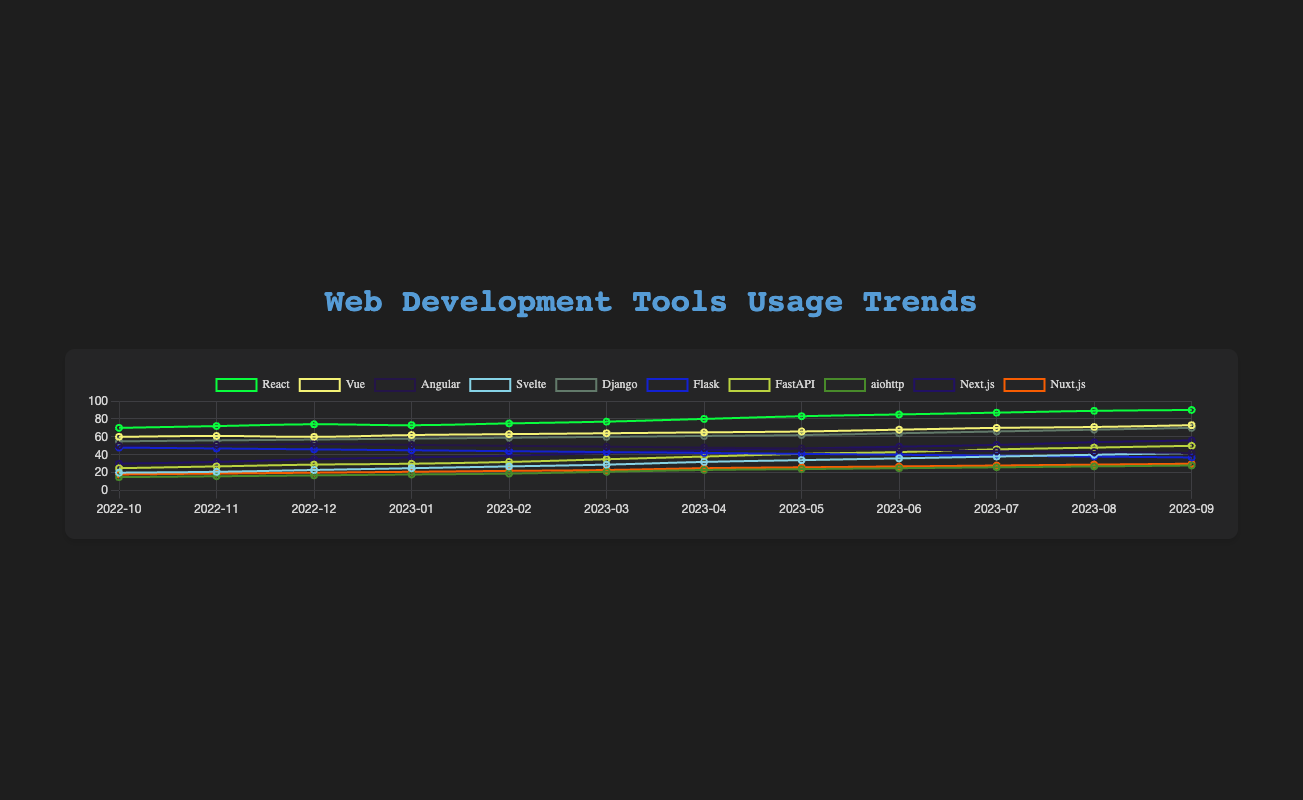What's the trend for React from October 2022 to September 2023? React's usage starts at 70% in October 2022 and shows a general upward trend, ending at 90% in September 2023, indicating increasing popularity.
Answer: Increasing Which tool has shown the most consistent increase in usage? By examining the slopes of the lines, we see that Django has a steady increase from 55% to 70%, and Next.js from 30% to 56% over the year. Both show consistent increases, but Next.js has a steeper slope, indicating a faster growth rate.
Answer: Next.js Between FastAPI and aiohttp, which had a higher usage in May 2023? FastAPI shows a usage of 41% while aiohttp shows 24% in May 2023.
Answer: FastAPI Compare the usage of Vue and Angular in March 2023. Which one was more popular? In March 2023, Vue has a usage of 64% and Angular has 49%, indicating Vue is more popular at that time.
Answer: Vue Which tool has the largest differential in usage between the starting and ending months? React shows the largest increase from 70% to 90%, a differential of 20%.
Answer: React What is the average usage of Svelte over the year? (20 + 21 + 23 + 25 + 27 + 29 + 32 + 34 + 36 + 38 + 40 + 42) / 12 = 30.083
Answer: 30.083 Which tool saw a decline in usage over the past year? Both Angular and Flask show declines. Angular goes from 50% to 42% and Flask from 48% to 37%.
Answer: Angular, Flask In which month did Django first surpass 60% usage? Django surpassed 60% usage in March 2023 (at 60%) and firmly passed it in April 2023 (at 61%).
Answer: April 2023 What visual indication suggests a tool is popular across the entire year? Tools whose lines are consistently higher on the y-axis, like React and Vue, indicate sustained popularity.
Answer: Higher lines Considering all the tools, which month shows the maximum variance in tool usage percentages? July 2023 shows wide ranges from React at 87% to aiohttp at 26%, indicating high variance.
Answer: July 2023 